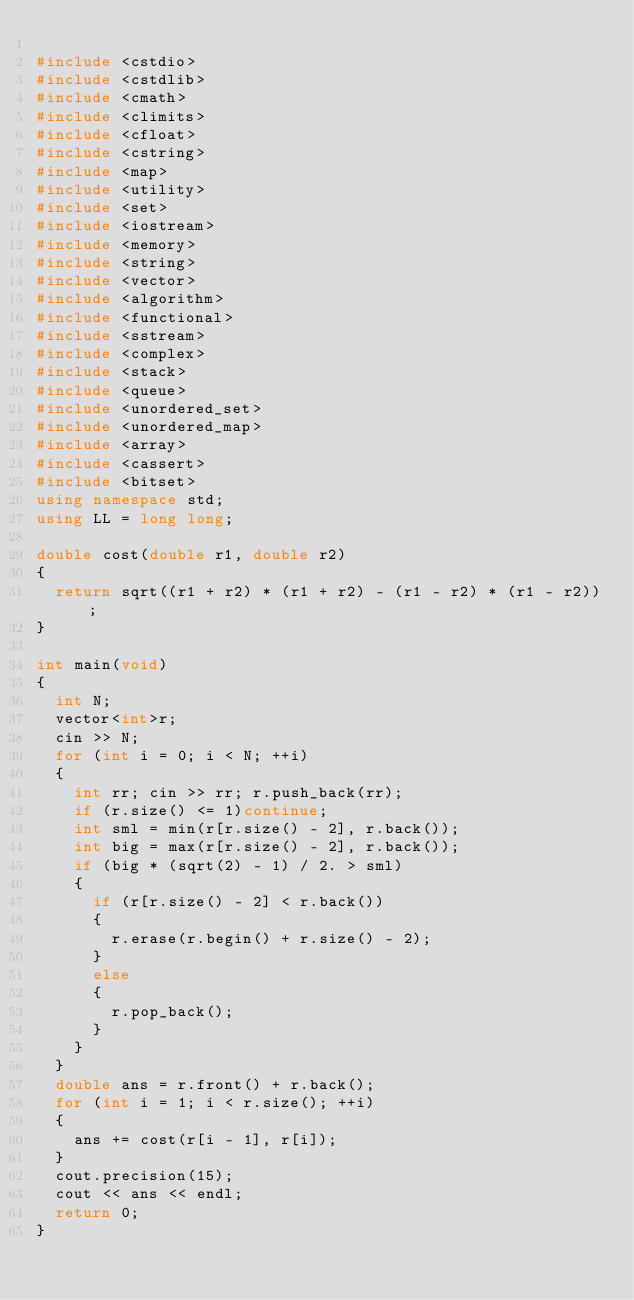<code> <loc_0><loc_0><loc_500><loc_500><_C++_>
#include <cstdio>
#include <cstdlib>
#include <cmath>
#include <climits>
#include <cfloat>
#include <cstring>
#include <map>
#include <utility>
#include <set>
#include <iostream>
#include <memory>
#include <string>
#include <vector>
#include <algorithm>
#include <functional>
#include <sstream>
#include <complex>
#include <stack>
#include <queue>
#include <unordered_set>
#include <unordered_map>
#include <array>
#include <cassert>
#include <bitset>
using namespace std;
using LL = long long;

double cost(double r1, double r2)
{
	return sqrt((r1 + r2) * (r1 + r2) - (r1 - r2) * (r1 - r2));
}

int main(void)
{
	int N;
	vector<int>r;
	cin >> N;
	for (int i = 0; i < N; ++i)
	{
		int rr; cin >> rr; r.push_back(rr);
		if (r.size() <= 1)continue;
		int sml = min(r[r.size() - 2], r.back());
		int big = max(r[r.size() - 2], r.back());
		if (big * (sqrt(2) - 1) / 2. > sml)
		{
			if (r[r.size() - 2] < r.back())
			{
				r.erase(r.begin() + r.size() - 2);
			}
			else
			{
				r.pop_back();
			}
		}
	}
	double ans = r.front() + r.back();
	for (int i = 1; i < r.size(); ++i)
	{
		ans += cost(r[i - 1], r[i]);
	}
	cout.precision(15);
	cout << ans << endl;
	return 0;
}</code> 